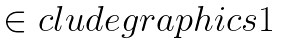<formula> <loc_0><loc_0><loc_500><loc_500>\begin{matrix} \in c l u d e g r a p h i c s { 1 } \end{matrix}</formula> 